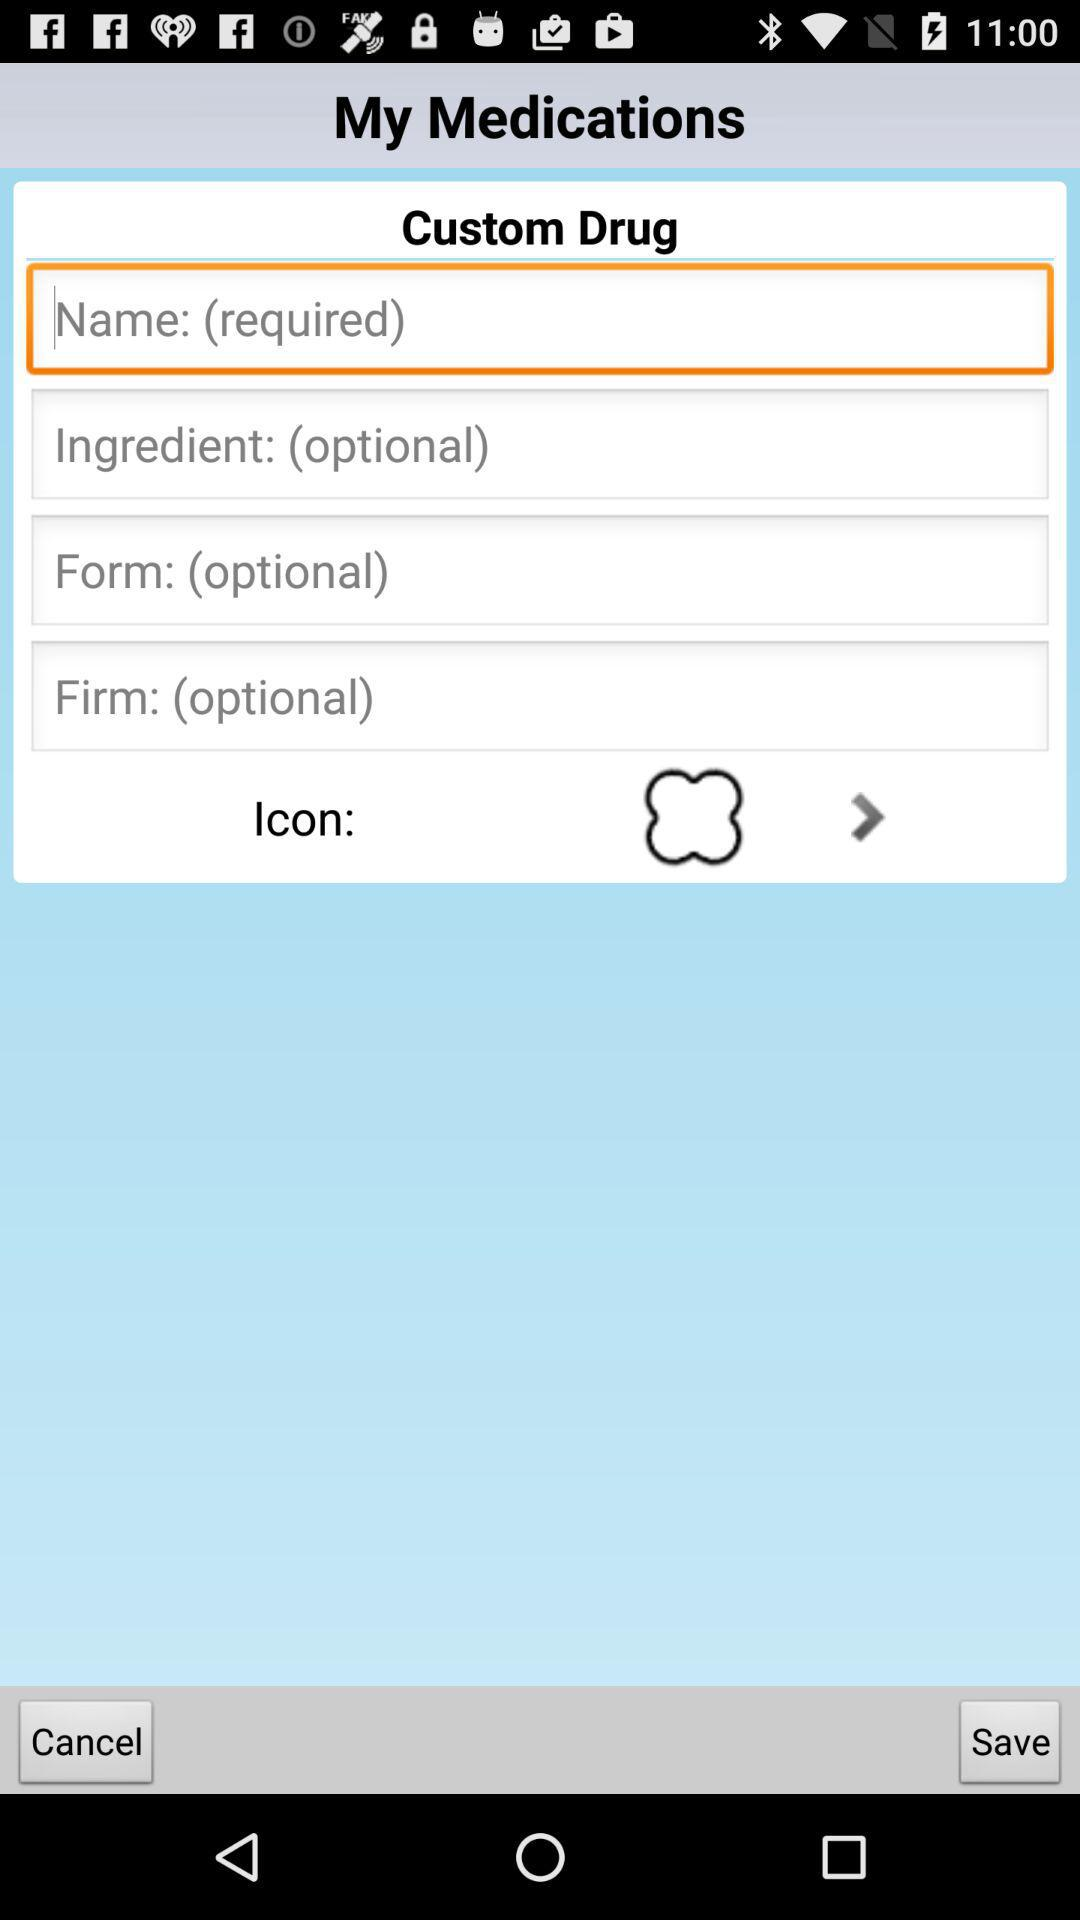Is the name required or optional? The name is "required". 